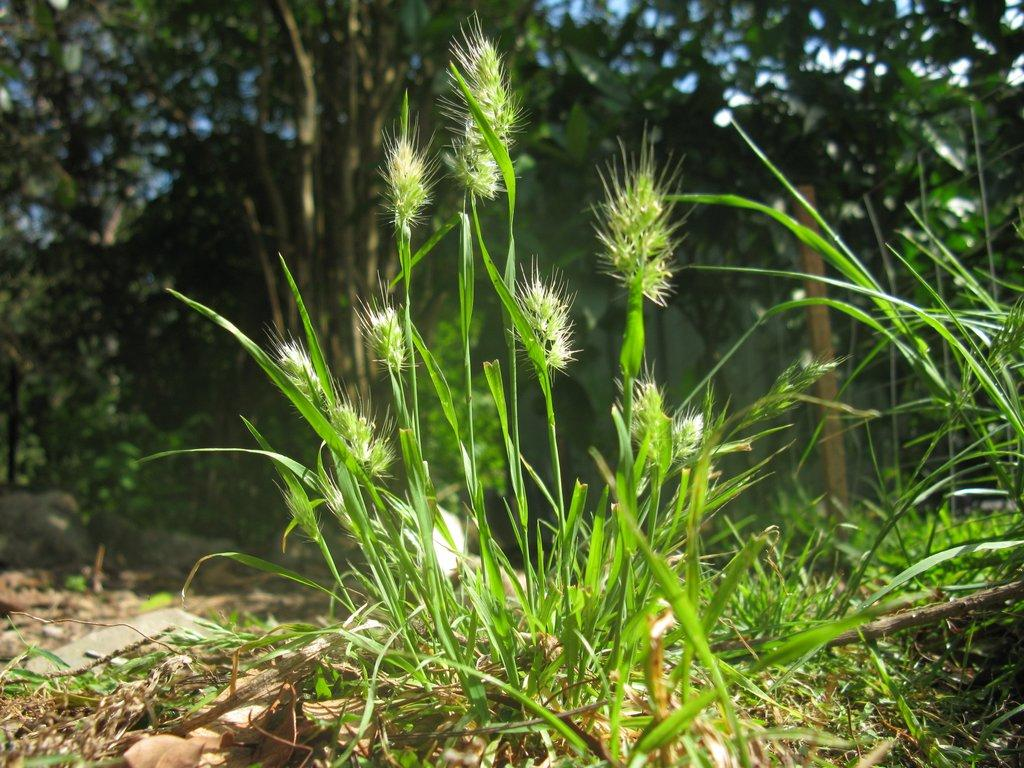What type of vegetation can be seen in the image? There is grass and flowers in the image. What can be seen in the background of the image? There are trees in the background of the image. What is visible in the sky in the image? The sky is visible in the image. What object with a distinct color is located on the right side of the image? There is a yellow color pole on the right side of the image. What type of dress is the toad wearing in the image? There is no toad present in the image, and therefore no dress can be observed. 